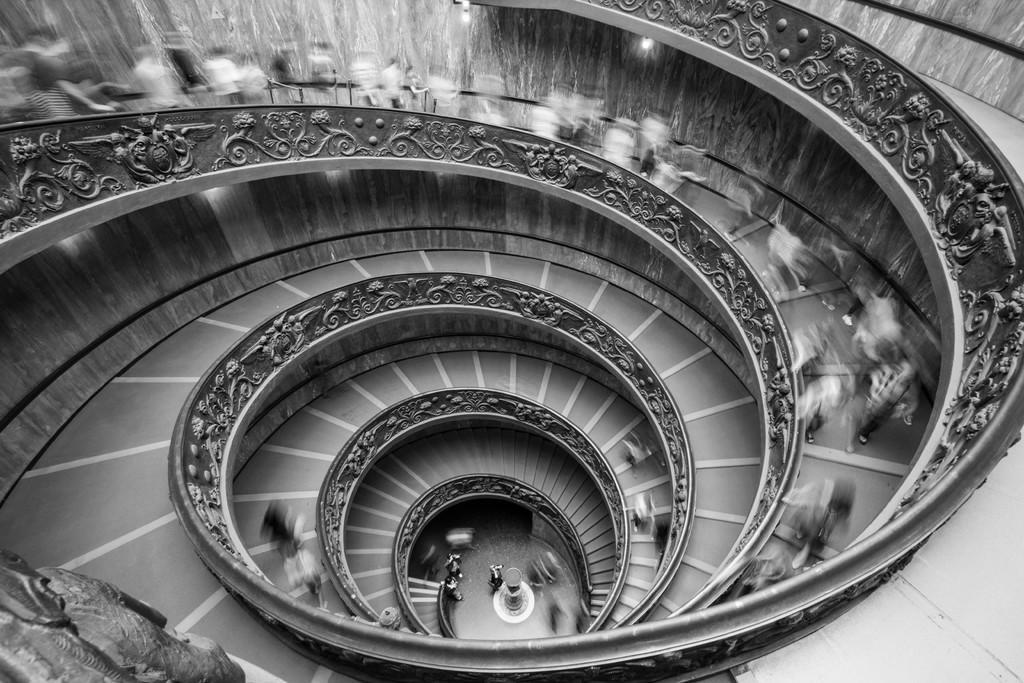Can you describe this image briefly? This is a black and white image, where we can see a round staircase which consists of a group of people on it. 